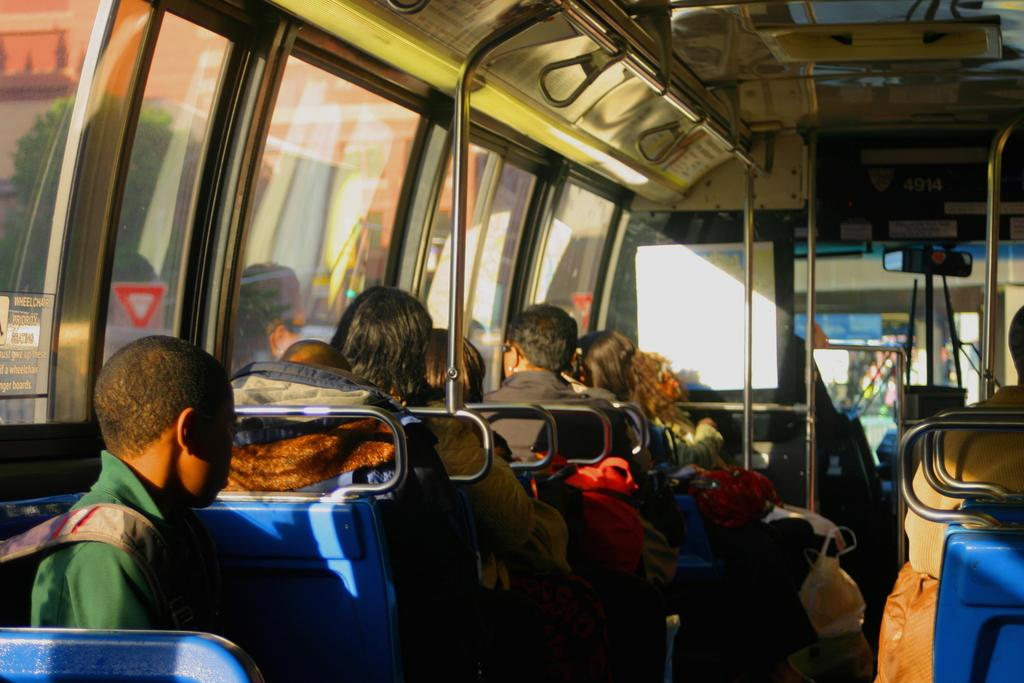Who can be seen in the image? There are people in the image. What are the people doing in the image? The people are sitting in a bus. Can you see a tiger walking on the bus in the image? No, there is no tiger present in the image. 